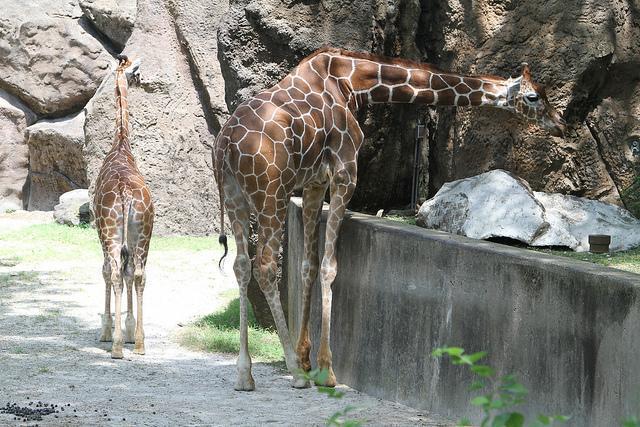How many giraffes are here?
Give a very brief answer. 2. How many giraffes are there?
Give a very brief answer. 2. 